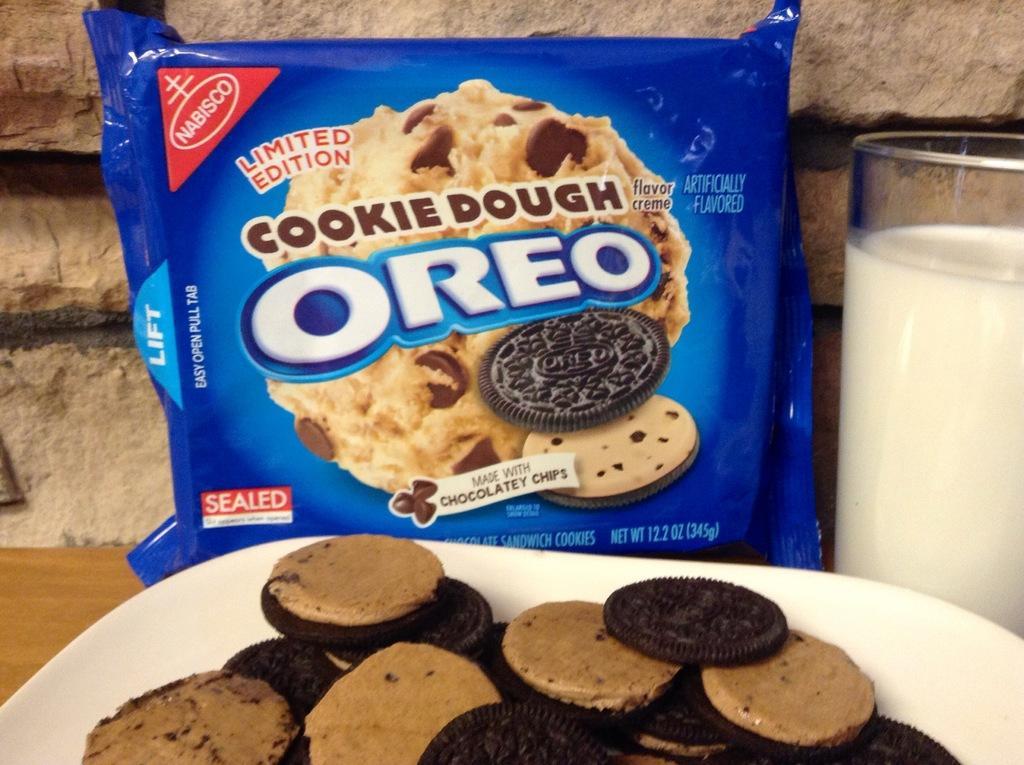How would you summarize this image in a sentence or two? In this image there is a food packet, milk, glass, plate, wooden surface and cream biscuits. In plate there are biscuits. 